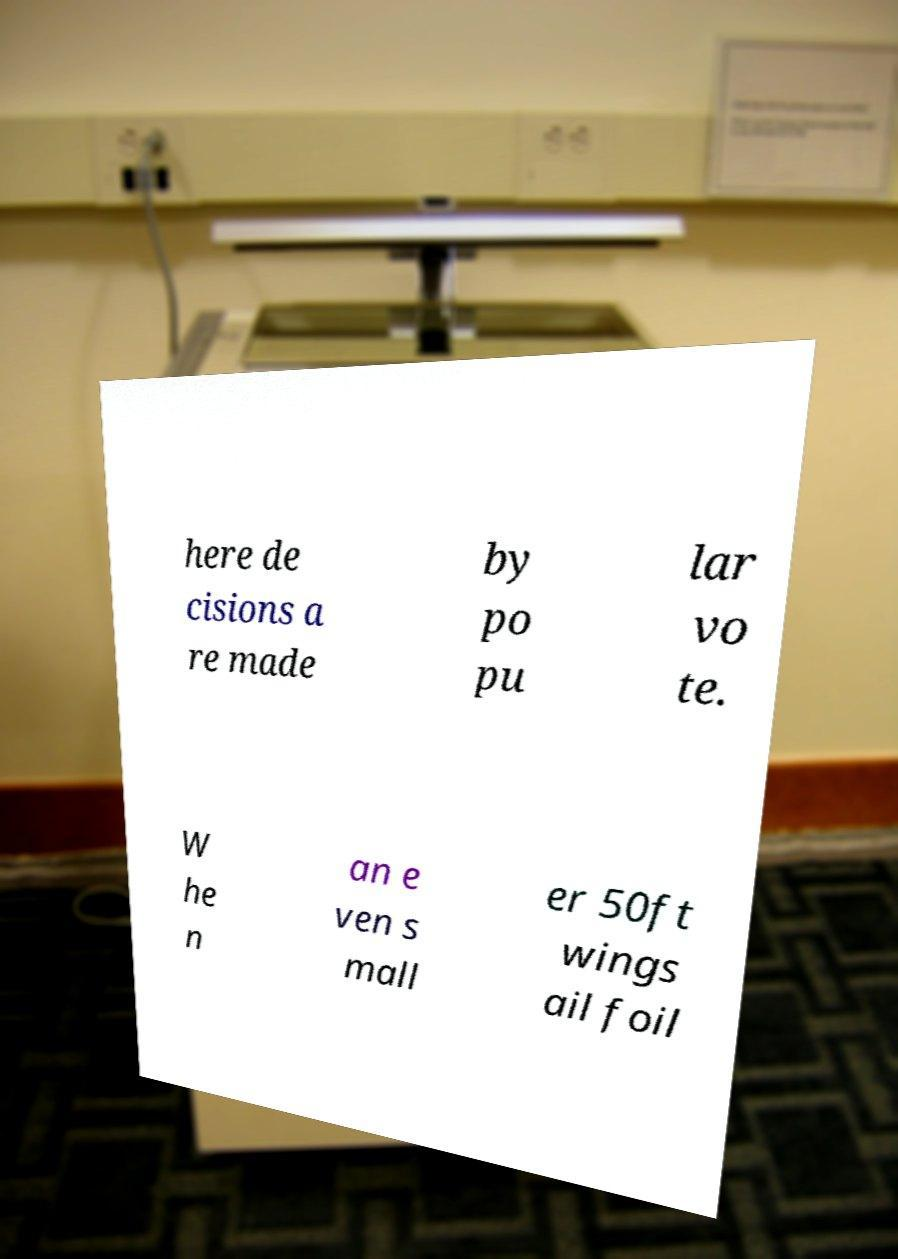Could you assist in decoding the text presented in this image and type it out clearly? here de cisions a re made by po pu lar vo te. W he n an e ven s mall er 50ft wings ail foil 